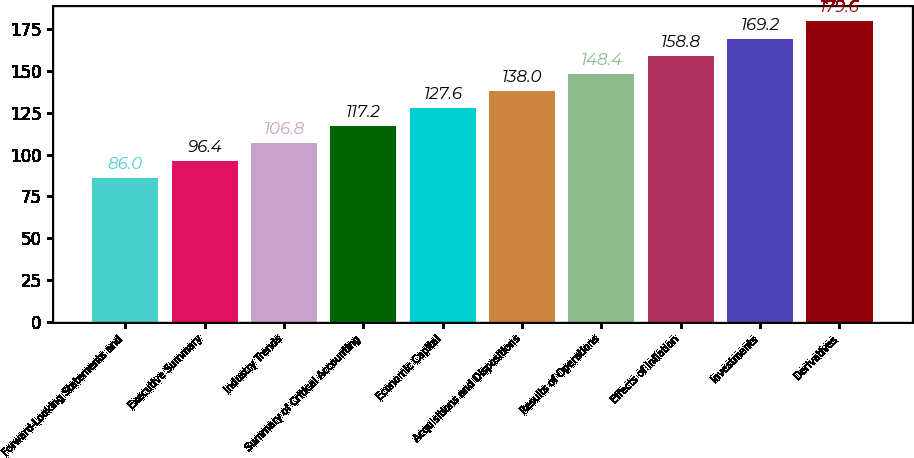Convert chart to OTSL. <chart><loc_0><loc_0><loc_500><loc_500><bar_chart><fcel>Forward-Looking Statements and<fcel>Executive Summary<fcel>Industry Trends<fcel>Summary of Critical Accounting<fcel>Economic Capital<fcel>Acquisitions and Dispositions<fcel>Results of Operations<fcel>Effects of Inflation<fcel>Investments<fcel>Derivatives<nl><fcel>86<fcel>96.4<fcel>106.8<fcel>117.2<fcel>127.6<fcel>138<fcel>148.4<fcel>158.8<fcel>169.2<fcel>179.6<nl></chart> 